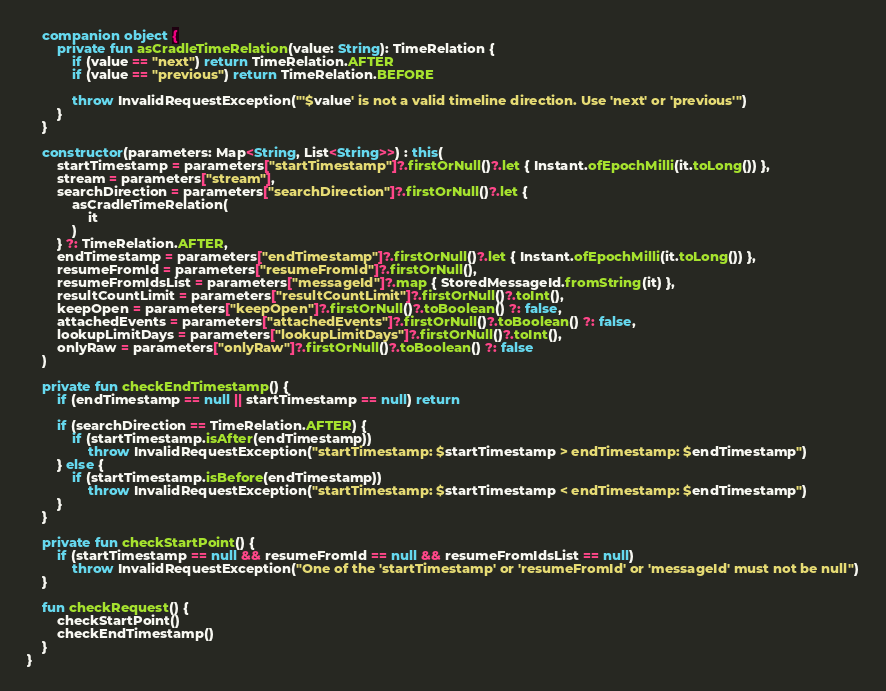Convert code to text. <code><loc_0><loc_0><loc_500><loc_500><_Kotlin_>    companion object {
        private fun asCradleTimeRelation(value: String): TimeRelation {
            if (value == "next") return TimeRelation.AFTER
            if (value == "previous") return TimeRelation.BEFORE

            throw InvalidRequestException("'$value' is not a valid timeline direction. Use 'next' or 'previous'")
        }
    }

    constructor(parameters: Map<String, List<String>>) : this(
        startTimestamp = parameters["startTimestamp"]?.firstOrNull()?.let { Instant.ofEpochMilli(it.toLong()) },
        stream = parameters["stream"],
        searchDirection = parameters["searchDirection"]?.firstOrNull()?.let {
            asCradleTimeRelation(
                it
            )
        } ?: TimeRelation.AFTER,
        endTimestamp = parameters["endTimestamp"]?.firstOrNull()?.let { Instant.ofEpochMilli(it.toLong()) },
        resumeFromId = parameters["resumeFromId"]?.firstOrNull(),
        resumeFromIdsList = parameters["messageId"]?.map { StoredMessageId.fromString(it) },
        resultCountLimit = parameters["resultCountLimit"]?.firstOrNull()?.toInt(),
        keepOpen = parameters["keepOpen"]?.firstOrNull()?.toBoolean() ?: false,
        attachedEvents = parameters["attachedEvents"]?.firstOrNull()?.toBoolean() ?: false,
        lookupLimitDays = parameters["lookupLimitDays"]?.firstOrNull()?.toInt(),
        onlyRaw = parameters["onlyRaw"]?.firstOrNull()?.toBoolean() ?: false
    )

    private fun checkEndTimestamp() {
        if (endTimestamp == null || startTimestamp == null) return

        if (searchDirection == TimeRelation.AFTER) {
            if (startTimestamp.isAfter(endTimestamp))
                throw InvalidRequestException("startTimestamp: $startTimestamp > endTimestamp: $endTimestamp")
        } else {
            if (startTimestamp.isBefore(endTimestamp))
                throw InvalidRequestException("startTimestamp: $startTimestamp < endTimestamp: $endTimestamp")
        }
    }

    private fun checkStartPoint() {
        if (startTimestamp == null && resumeFromId == null && resumeFromIdsList == null)
            throw InvalidRequestException("One of the 'startTimestamp' or 'resumeFromId' or 'messageId' must not be null")
    }

    fun checkRequest() {
        checkStartPoint()
        checkEndTimestamp()
    }
}

</code> 